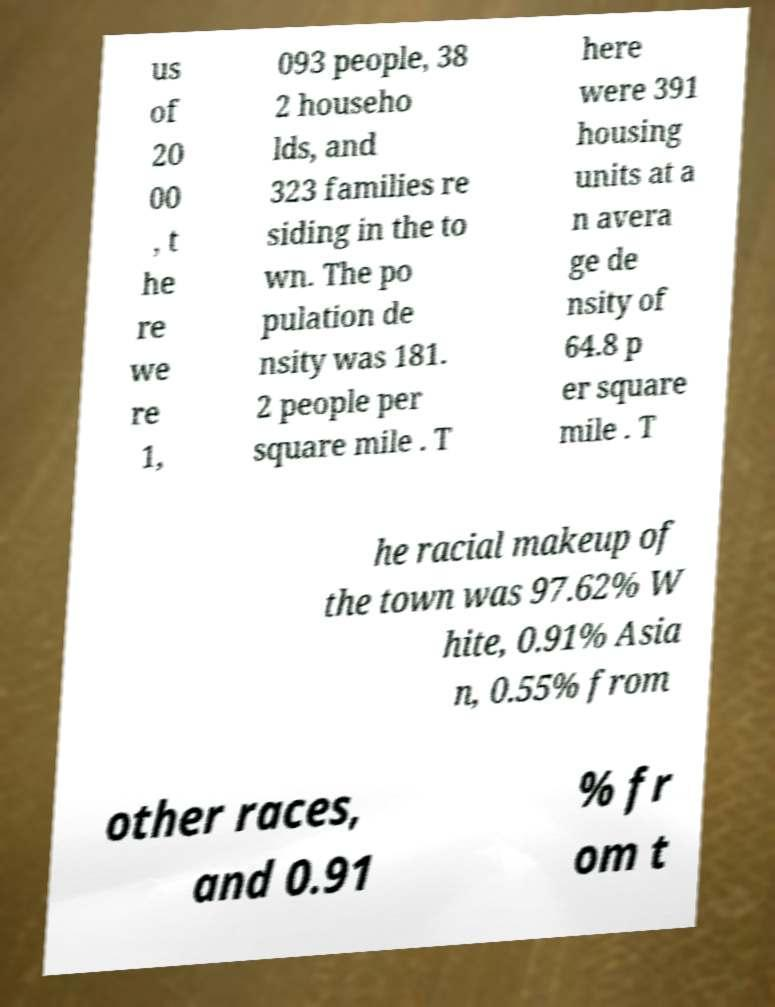Could you assist in decoding the text presented in this image and type it out clearly? us of 20 00 , t he re we re 1, 093 people, 38 2 househo lds, and 323 families re siding in the to wn. The po pulation de nsity was 181. 2 people per square mile . T here were 391 housing units at a n avera ge de nsity of 64.8 p er square mile . T he racial makeup of the town was 97.62% W hite, 0.91% Asia n, 0.55% from other races, and 0.91 % fr om t 